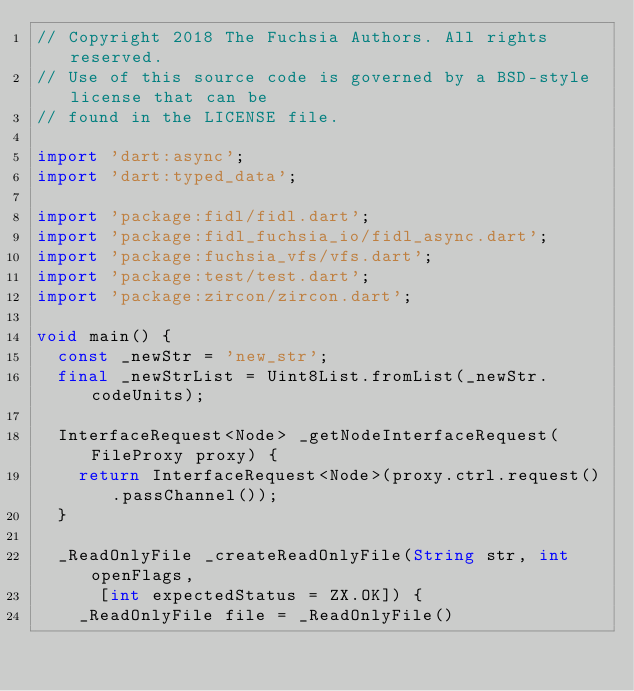Convert code to text. <code><loc_0><loc_0><loc_500><loc_500><_Dart_>// Copyright 2018 The Fuchsia Authors. All rights reserved.
// Use of this source code is governed by a BSD-style license that can be
// found in the LICENSE file.

import 'dart:async';
import 'dart:typed_data';

import 'package:fidl/fidl.dart';
import 'package:fidl_fuchsia_io/fidl_async.dart';
import 'package:fuchsia_vfs/vfs.dart';
import 'package:test/test.dart';
import 'package:zircon/zircon.dart';

void main() {
  const _newStr = 'new_str';
  final _newStrList = Uint8List.fromList(_newStr.codeUnits);

  InterfaceRequest<Node> _getNodeInterfaceRequest(FileProxy proxy) {
    return InterfaceRequest<Node>(proxy.ctrl.request().passChannel());
  }

  _ReadOnlyFile _createReadOnlyFile(String str, int openFlags,
      [int expectedStatus = ZX.OK]) {
    _ReadOnlyFile file = _ReadOnlyFile()</code> 